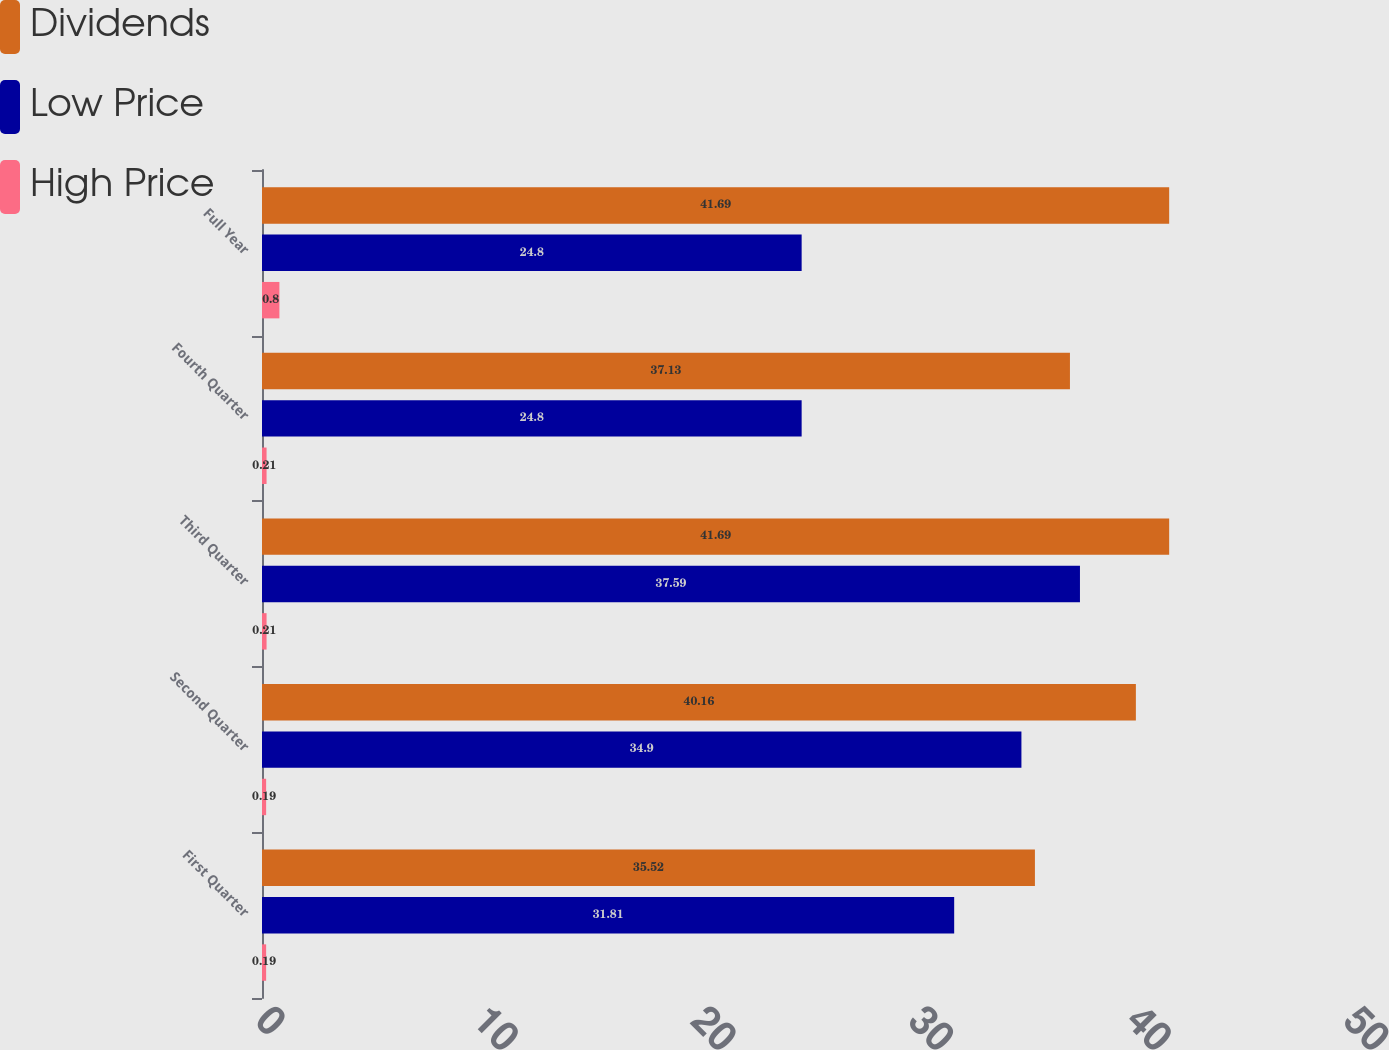<chart> <loc_0><loc_0><loc_500><loc_500><stacked_bar_chart><ecel><fcel>First Quarter<fcel>Second Quarter<fcel>Third Quarter<fcel>Fourth Quarter<fcel>Full Year<nl><fcel>Dividends<fcel>35.52<fcel>40.16<fcel>41.69<fcel>37.13<fcel>41.69<nl><fcel>Low Price<fcel>31.81<fcel>34.9<fcel>37.59<fcel>24.8<fcel>24.8<nl><fcel>High Price<fcel>0.19<fcel>0.19<fcel>0.21<fcel>0.21<fcel>0.8<nl></chart> 